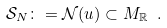Convert formula to latex. <formula><loc_0><loc_0><loc_500><loc_500>\mathcal { S } _ { N } \colon = \mathcal { N } ( u ) \subset M _ { \mathbb { R } } \ .</formula> 